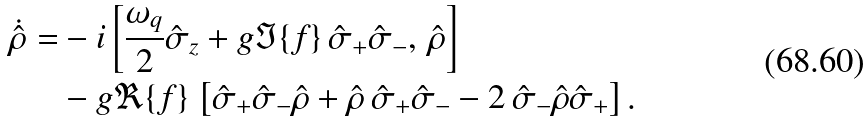<formula> <loc_0><loc_0><loc_500><loc_500>\dot { \hat { \rho } } = & - i \left [ \frac { \omega _ { q } } { 2 } \hat { \sigma } _ { z } + g \Im \{ f \} \, \hat { \sigma } _ { + } \hat { \sigma } _ { - } , \, \hat { \rho } \right ] \\ & - g \Re \{ f \} \, \left [ \hat { \sigma } _ { + } \hat { \sigma } _ { - } \hat { \rho } + \hat { \rho } \, \hat { \sigma } _ { + } \hat { \sigma } _ { - } - 2 \, \hat { \sigma } _ { - } \hat { \rho } \hat { \sigma } _ { + } \right ] .</formula> 